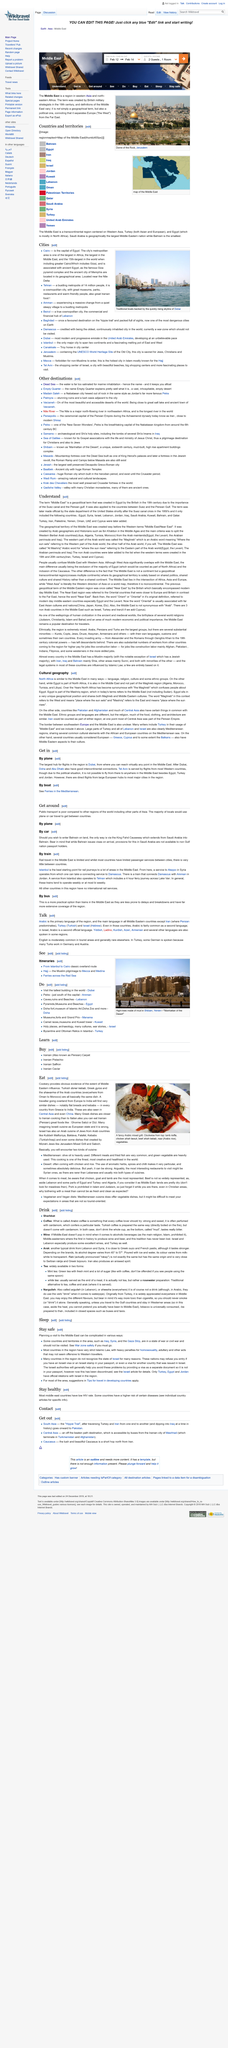Draw attention to some important aspects in this diagram. Overland travel from Europe to India reveals similar dishes, including flat breads and kebabs, in every country from Greece to India. Cookery provides clear evidence of the extent of Middle Eastern influence. 